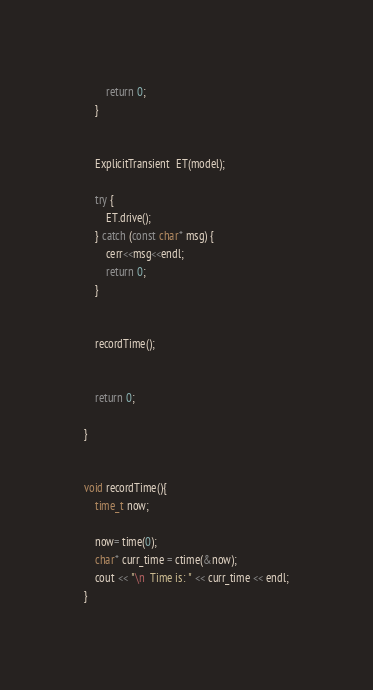Convert code to text. <code><loc_0><loc_0><loc_500><loc_500><_C++_>        return 0;
    }
    
    
    ExplicitTransient  ET(model);
    
    try {
        ET.drive();
    } catch (const char* msg) {
        cerr<<msg<<endl;
        return 0;
    }
    
    
    recordTime();
    

	return 0;

}


void recordTime(){
    time_t now;
    
    now= time(0);
    char* curr_time = ctime(&now);
    cout << "\n  Time is: " << curr_time << endl;
}
</code> 